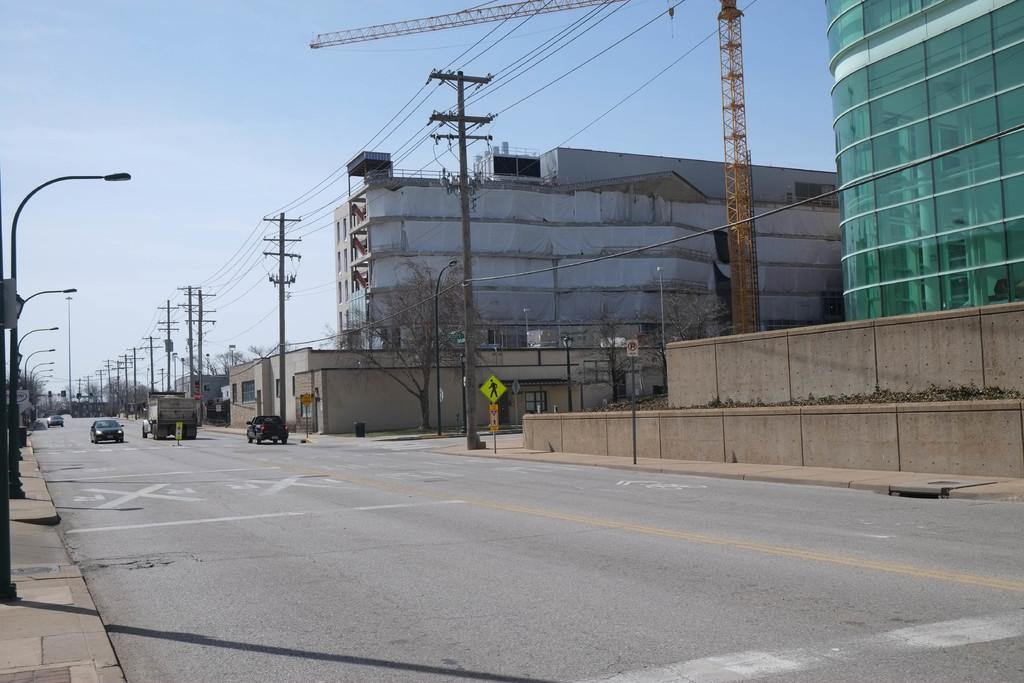How would you summarize this image in a sentence or two? This image is clicked on a street, in the middle there are vehicles going on the road and on the right side there are buildings inside fence with electric poles outside on the road and street lights on the left side of footpath and above its sky. 